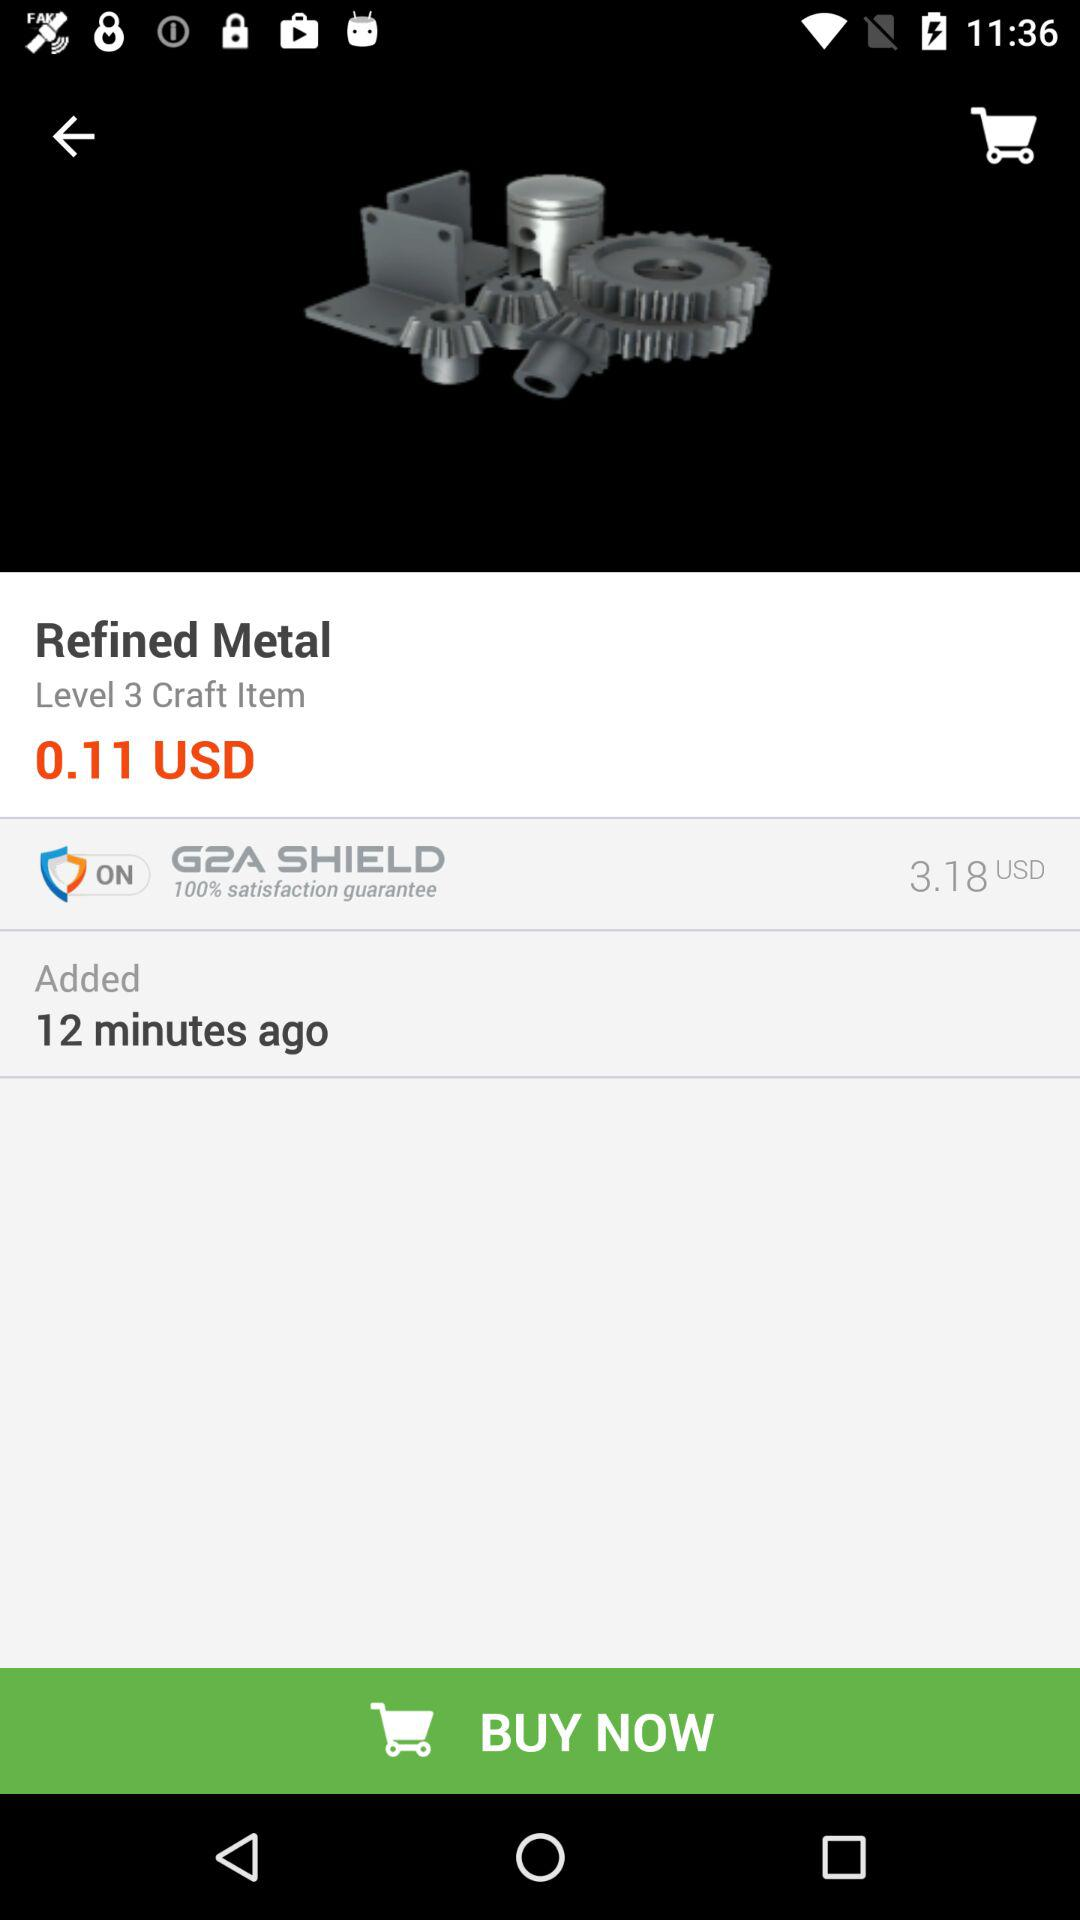What is the price of the refined metal? The price is $0.11 USD. 